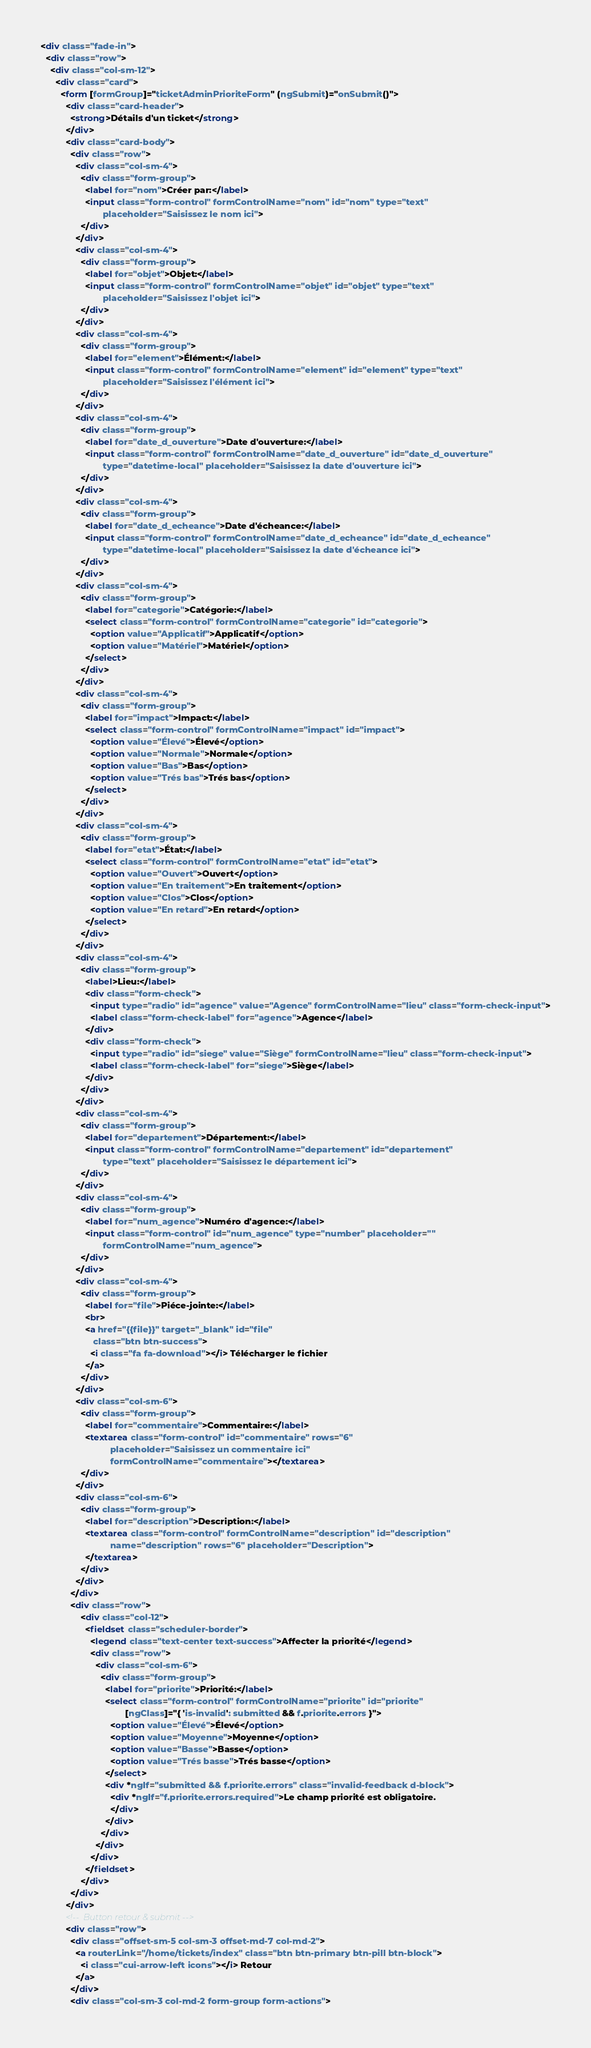Convert code to text. <code><loc_0><loc_0><loc_500><loc_500><_HTML_><div class="fade-in">
  <div class="row">
    <div class="col-sm-12">
      <div class="card">
        <form [formGroup]="ticketAdminPrioriteForm" (ngSubmit)="onSubmit()">
          <div class="card-header">
            <strong>Détails d'un ticket</strong>
          </div>
          <div class="card-body">
            <div class="row">
              <div class="col-sm-4">
                <div class="form-group">
                  <label for="nom">Créer par:</label>
                  <input class="form-control" formControlName="nom" id="nom" type="text"
                         placeholder="Saisissez le nom ici">
                </div>
              </div>
              <div class="col-sm-4">
                <div class="form-group">
                  <label for="objet">Objet:</label>
                  <input class="form-control" formControlName="objet" id="objet" type="text"
                         placeholder="Saisissez l'objet ici">
                </div>
              </div>
              <div class="col-sm-4">
                <div class="form-group">
                  <label for="element">Élément:</label>
                  <input class="form-control" formControlName="element" id="element" type="text"
                         placeholder="Saisissez l'élément ici">
                </div>
              </div>
              <div class="col-sm-4">
                <div class="form-group">
                  <label for="date_d_ouverture">Date d'ouverture:</label>
                  <input class="form-control" formControlName="date_d_ouverture" id="date_d_ouverture"
                         type="datetime-local" placeholder="Saisissez la date d'ouverture ici">
                </div>
              </div>
              <div class="col-sm-4">
                <div class="form-group">
                  <label for="date_d_echeance">Date d'écheance:</label>
                  <input class="form-control" formControlName="date_d_echeance" id="date_d_echeance"
                         type="datetime-local" placeholder="Saisissez la date d'écheance ici">
                </div>
              </div>
              <div class="col-sm-4">
                <div class="form-group">
                  <label for="categorie">Catégorie:</label>
                  <select class="form-control" formControlName="categorie" id="categorie">
                    <option value="Applicatif">Applicatif</option>
                    <option value="Matériel">Matériel</option>
                  </select>
                </div>
              </div>
              <div class="col-sm-4">
                <div class="form-group">
                  <label for="impact">Impact:</label>
                  <select class="form-control" formControlName="impact" id="impact">
                    <option value="Élevé">Élevé</option>
                    <option value="Normale">Normale</option>
                    <option value="Bas">Bas</option>
                    <option value="Trés bas">Trés bas</option>
                  </select>
                </div>
              </div>
              <div class="col-sm-4">
                <div class="form-group">
                  <label for="etat">État:</label>
                  <select class="form-control" formControlName="etat" id="etat">
                    <option value="Ouvert">Ouvert</option>
                    <option value="En traitement">En traitement</option>
                    <option value="Clos">Clos</option>
                    <option value="En retard">En retard</option>
                  </select>
                </div>
              </div>
              <div class="col-sm-4">
                <div class="form-group">
                  <label>Lieu:</label>
                  <div class="form-check">
                    <input type="radio" id="agence" value="Agence" formControlName="lieu" class="form-check-input">
                    <label class="form-check-label" for="agence">Agence</label>
                  </div>
                  <div class="form-check">
                    <input type="radio" id="siege" value="Siège" formControlName="lieu" class="form-check-input">
                    <label class="form-check-label" for="siege">Siège</label>
                  </div>
                </div>
              </div>
              <div class="col-sm-4">
                <div class="form-group">
                  <label for="departement">Département:</label>
                  <input class="form-control" formControlName="departement" id="departement"
                         type="text" placeholder="Saisissez le département ici">
                </div>
              </div>
              <div class="col-sm-4">
                <div class="form-group">
                  <label for="num_agence">Numéro d'agence:</label>
                  <input class="form-control" id="num_agence" type="number" placeholder=""
                         formControlName="num_agence">
                </div>
              </div>
              <div class="col-sm-4">
                <div class="form-group">
                  <label for="file">Piéce-jointe:</label>
                  <br>
                  <a href="{{file}}" target="_blank" id="file"
                     class="btn btn-success">
                    <i class="fa fa-download"></i> Télécharger le fichier
                  </a>
                </div>
              </div>
              <div class="col-sm-6">
                <div class="form-group">
                  <label for="commentaire">Commentaire:</label>
                  <textarea class="form-control" id="commentaire" rows="6"
                            placeholder="Saisissez un commentaire ici"
                            formControlName="commentaire"></textarea>
                </div>
              </div>
              <div class="col-sm-6">
                <div class="form-group">
                  <label for="description">Description:</label>
                  <textarea class="form-control" formControlName="description" id="description"
                            name="description" rows="6" placeholder="Description">
                  </textarea>
                </div>
              </div>
            </div>
            <div class="row">
                <div class="col-12">
                  <fieldset class="scheduler-border">
                    <legend class="text-center text-success">Affecter la priorité</legend>
                    <div class="row">
                      <div class="col-sm-6">
                        <div class="form-group">
                          <label for="priorite">Priorité:</label>
                          <select class="form-control" formControlName="priorite" id="priorite"
                                  [ngClass]="{ 'is-invalid': submitted && f.priorite.errors }">
                            <option value="Élevé">Élevé</option>
                            <option value="Moyenne">Moyenne</option>
                            <option value="Basse">Basse</option>
                            <option value="Trés basse">Trés basse</option>
                          </select>
                          <div *ngIf="submitted && f.priorite.errors" class="invalid-feedback d-block">
                            <div *ngIf="f.priorite.errors.required">Le champ priorité est obligatoire.
                            </div>
                          </div>
                        </div>
                      </div>
                    </div>
                  </fieldset>
                </div>
            </div>
          </div>
          <!--  Button retour & submit -->
          <div class="row">
            <div class="offset-sm-5 col-sm-3 offset-md-7 col-md-2">
              <a routerLink="/home/tickets/index" class="btn btn-primary btn-pill btn-block">
                <i class="cui-arrow-left icons"></i> Retour
              </a>
            </div>
            <div class="col-sm-3 col-md-2 form-group form-actions"></code> 